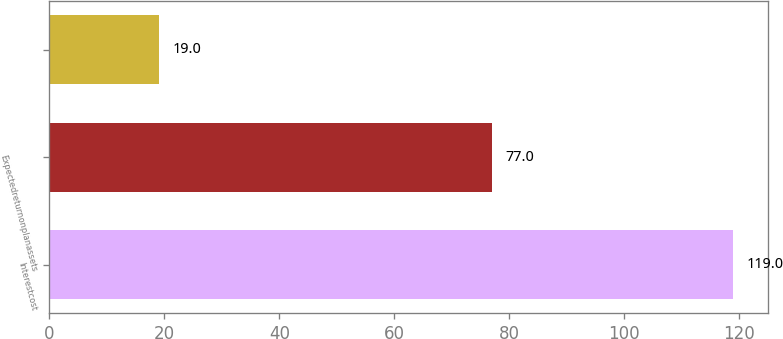Convert chart to OTSL. <chart><loc_0><loc_0><loc_500><loc_500><bar_chart><fcel>Interestcost<fcel>Expectedreturnonplanassets<fcel>Unnamed: 2<nl><fcel>119<fcel>77<fcel>19<nl></chart> 